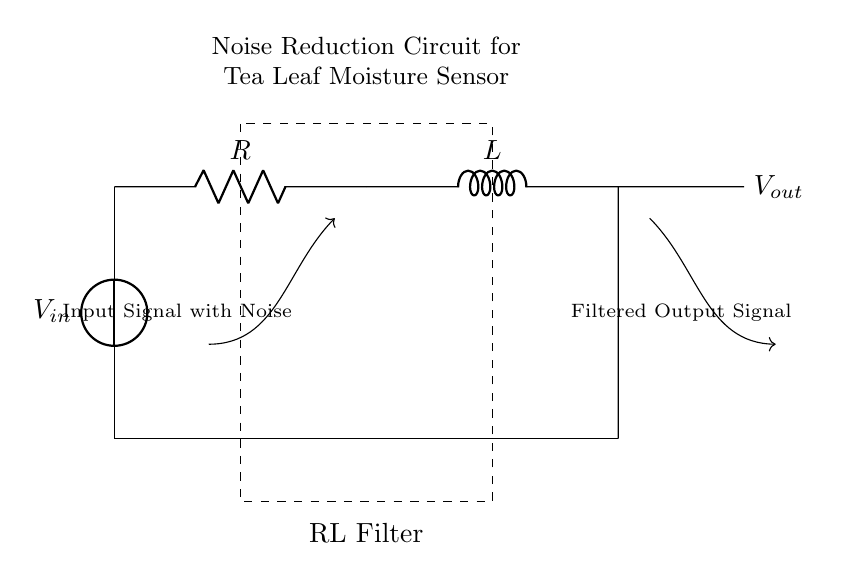What type of filter is illustrated in the circuit? The circuit is an RL filter, indicated by the presence of a resistor (R) and an inductor (L) connected in series. This combination is used to filter out high-frequency noise from the input signal.
Answer: RL filter What does the dashed rectangle represent in the circuit diagram? The dashed rectangle encloses the components that constitute the RL filter, visually indicating the section of the circuit dedicated to noise reduction. This helps in understanding that the noise filtering is a critical part of the overall design.
Answer: RL Filter What is the purpose of the inductor in the circuit? The inductor (L) serves to resist changes in current and to filter out high-frequency noise, allowing only lower frequencies to pass. This is a characteristic function of inductors in filtering applications, making them essential for smoothing out signal variations.
Answer: Noise reduction What signal is applied to the input of this circuit? The input is described as an "Input Signal with Noise." This suggests that the signal arriving at the circuit consists of both the desired signal and unwanted noise components.
Answer: Input signal with noise What is the output of this circuit called? The output is labeled as "Filtered Output Signal," indicating that the purpose of the RL filter is to process the input signal and reduce the noise, resulting in a cleaner output signal.
Answer: Filtered Output Signal Which component is primarily responsible for the noise reduction in this RL filter? The resistor (R) and the inductor (L) work together, but the inductor is primarily responsible for filtering out high-frequency noise due to its characteristic of opposing rapid changes in current.
Answer: Inductor What is the relationship between the input and output signals in this circuit? The output signal is a cleaner version of the input signal with noise; the RL filter reduces high-frequency components, resulting in a smoother output. The relationship is demonstrated by the arrows leading from input to output, indicating signal processing.
Answer: Cleaned signal 